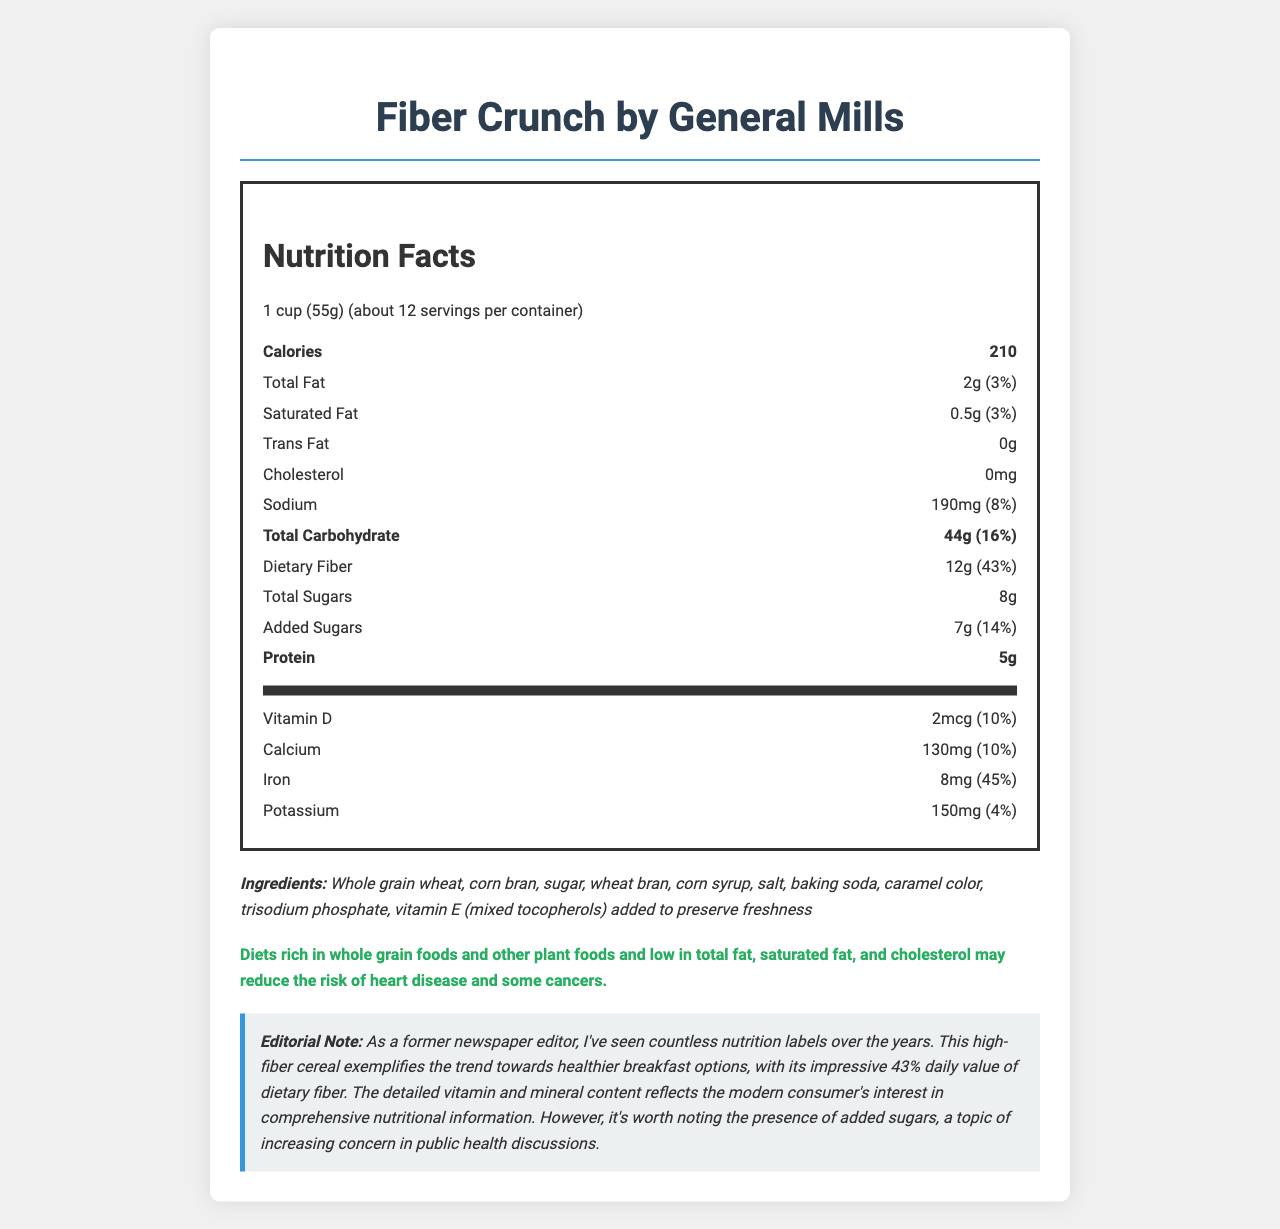what is the serving size for Fiber Crunch? The serving size is explicitly mentioned in the document as "1 cup (55g)".
Answer: 1 cup (55g) how many servings are in a container? The document states that there are "about 12" servings per container.
Answer: about 12 what is the amount of dietary fiber per serving? The amount of dietary fiber per serving is listed as "12g" in the nutrition facts.
Answer: 12g how much is the daily value percentage of iron in Fiber Crunch? The daily value percentage for iron is shown as "45%" on the label.
Answer: 45% what is the total amount of sugars in a serving, including added sugars? The total sugars in a serving is "8g", with "7g" coming from added sugars.
Answer: 8g how much sodium does one serving contain? One serving contains "190mg" of sodium.
Answer: 190mg which vitamin has the highest percentage daily value? A. Vitamin D B. Folate C. Niacin D. Riboflavin Folate has a daily value percentage of 80%, which is higher than the other vitamins listed.
Answer: B. Folate what is the amount of protein per serving? A. 2g B. 4g C. 5g D. 7g The nutrition label lists "5g" of protein per serving.
Answer: C. 5g does Fiber Crunch contain any cholesterol? The document states that cholesterol content is "0mg".
Answer: No is the product high in dietary fiber? The dietary fiber content per serving is 12g, which is 43% of the daily value, indicating that it is high in dietary fiber.
Answer: Yes list the first three ingredients in Fiber Crunch The first three ingredients listed are "whole grain wheat", "corn bran", and "sugar".
Answer: Whole grain wheat, corn bran, sugar summarize the key nutritional aspects of Fiber Crunch cereal. The summary provides a comprehensive overview of the main nutritional points, vitamins, and ingredients mentioned in the document.
Answer: Fiber Crunch is a high-fiber breakfast cereal by General Mills. It has 210 calories per serving, 2g of total fat, 12g of dietary fiber making up 43% of the daily value, and 5g of protein. It contains a significant amount of vitamins and minerals, such as 45% daily value of iron and 80% daily value of folate. However, it also contains 8g of sugars, including 7g of added sugars. The ingredients include whole grain wheat, corn bran, and some sugars. Overall, it offers a healthy mix with some sugars present. does the document mention the calorie count for Fiber Crunch? The document clearly states that Fiber Crunch contains 210 calories per serving.
Answer: Yes what specific health claim is made about the cereal? The health claim is stated in a bold section as "Diets rich in whole grain foods and other plant foods and low in total fat, saturated fat, and cholesterol may reduce the risk of heart disease and some cancers."
Answer: Diets rich in whole grain foods and other plant foods and low in total fat, saturated fat, and cholesterol may reduce the risk of heart disease and some cancers. what is the content of potassium per serving? The document lists the potassium content as "150mg" per serving.
Answer: 150mg what preservatives are used in Fiber Crunch? The document lists "vitamin E (mixed tocopherols)" as a preservative to preserve freshness.
Answer: Vitamin E (mixed tocopherols) added to preserve freshness how much vitamin B12 does one serving of Fiber Crunch provide? One serving provides "2mcg" of vitamin B12.
Answer: 2mcg is the cereal company located in the US? The document does not provide any information about the location of the manufacturer.
Answer: Cannot be determined what does the editorial note highlight about this cereal? The note mentions that the cereal reflects a trend towards healthier breakfast options with significant dietary fiber and comprehensive nutritional details, but also notes concerns about added sugars.
Answer: The editorial note highlights the high fiber content, detailed vitamin and mineral information, and the presence of added sugars. 